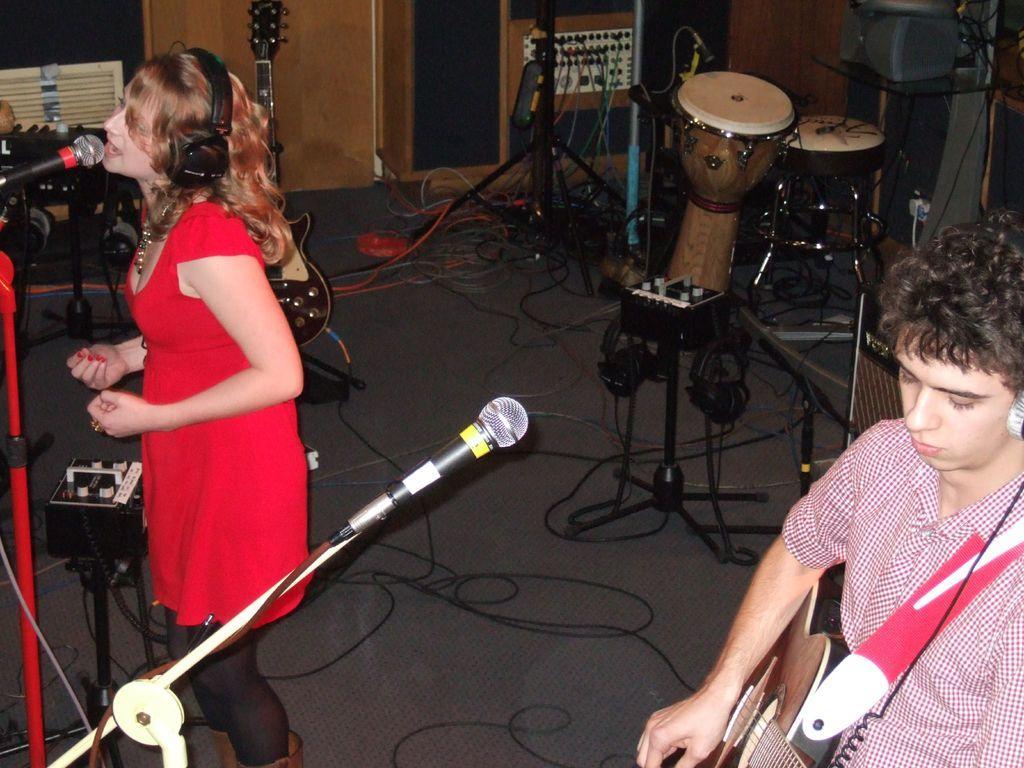In one or two sentences, can you explain what this image depicts? This is a picture, In a picture the two persons were playing a music the women in red dress were singing a song the boy holding a guitar. The floor is full of cables background of the two persons are the music instruments. 